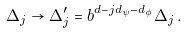Convert formula to latex. <formula><loc_0><loc_0><loc_500><loc_500>\Delta _ { j } \rightarrow \Delta ^ { \prime } _ { j } = b ^ { d - j d _ { \psi } - d _ { \phi } } \Delta _ { j } \, .</formula> 